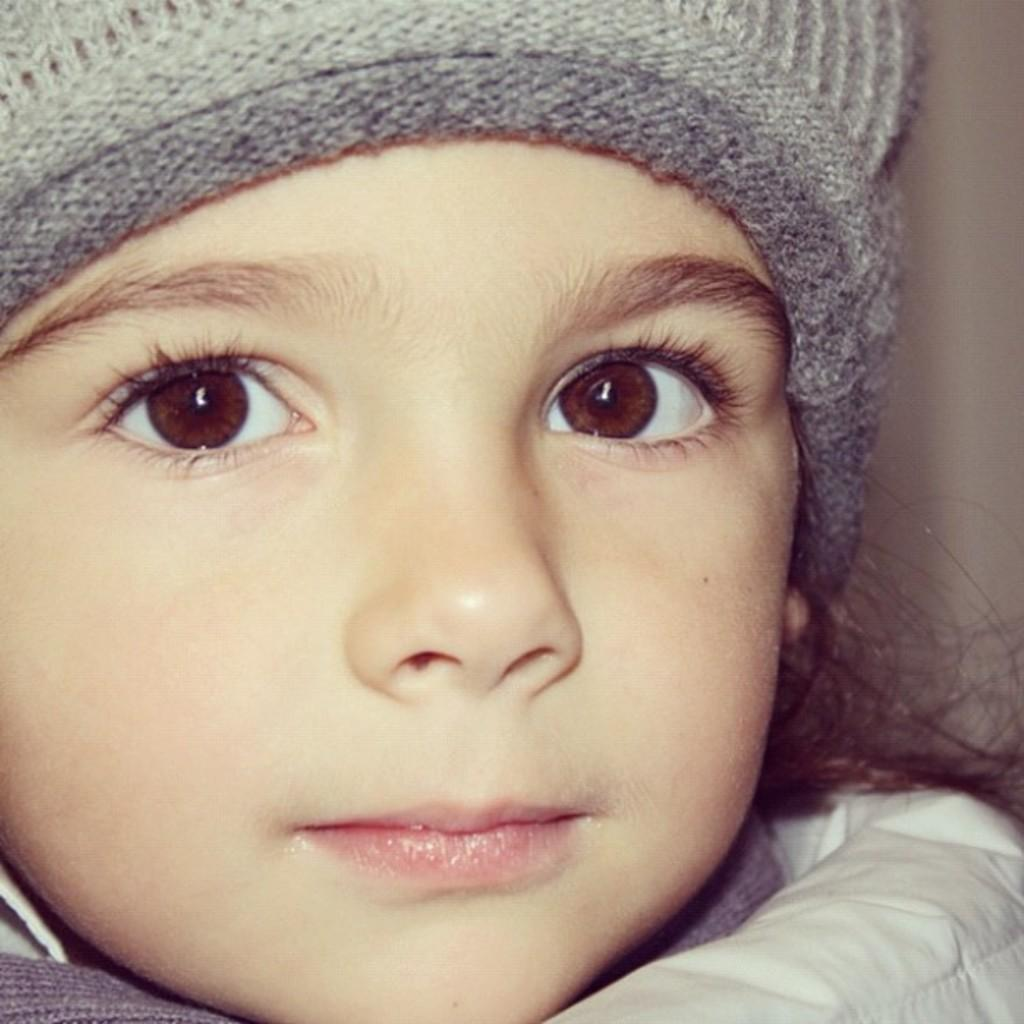Who is the main subject in the image? There is a girl in the image. What is the girl wearing on her head? The girl is wearing a cap on her head. What type of toothpaste is the girl using in the image? There is no toothpaste present in the image. Can you see a hill in the background of the image? The provided facts do not mention a hill or any background elements, so it cannot be determined from the image. 